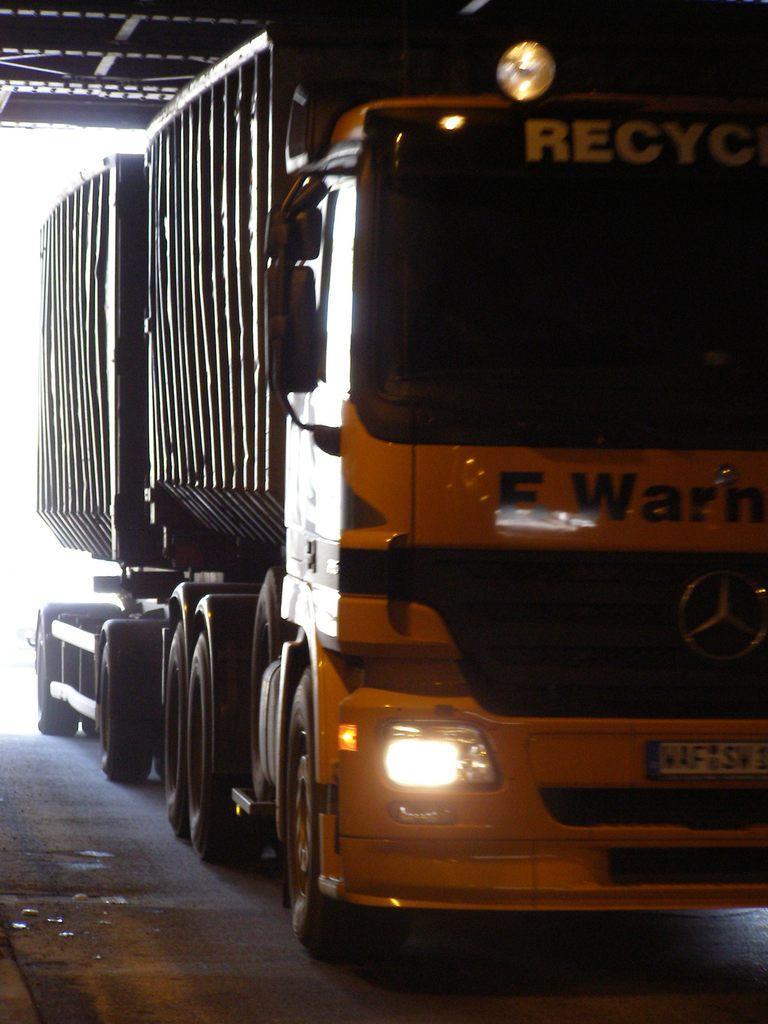Please provide a concise description of this image. In this image there is a big goods vehicle on the floor under the roof shed. 